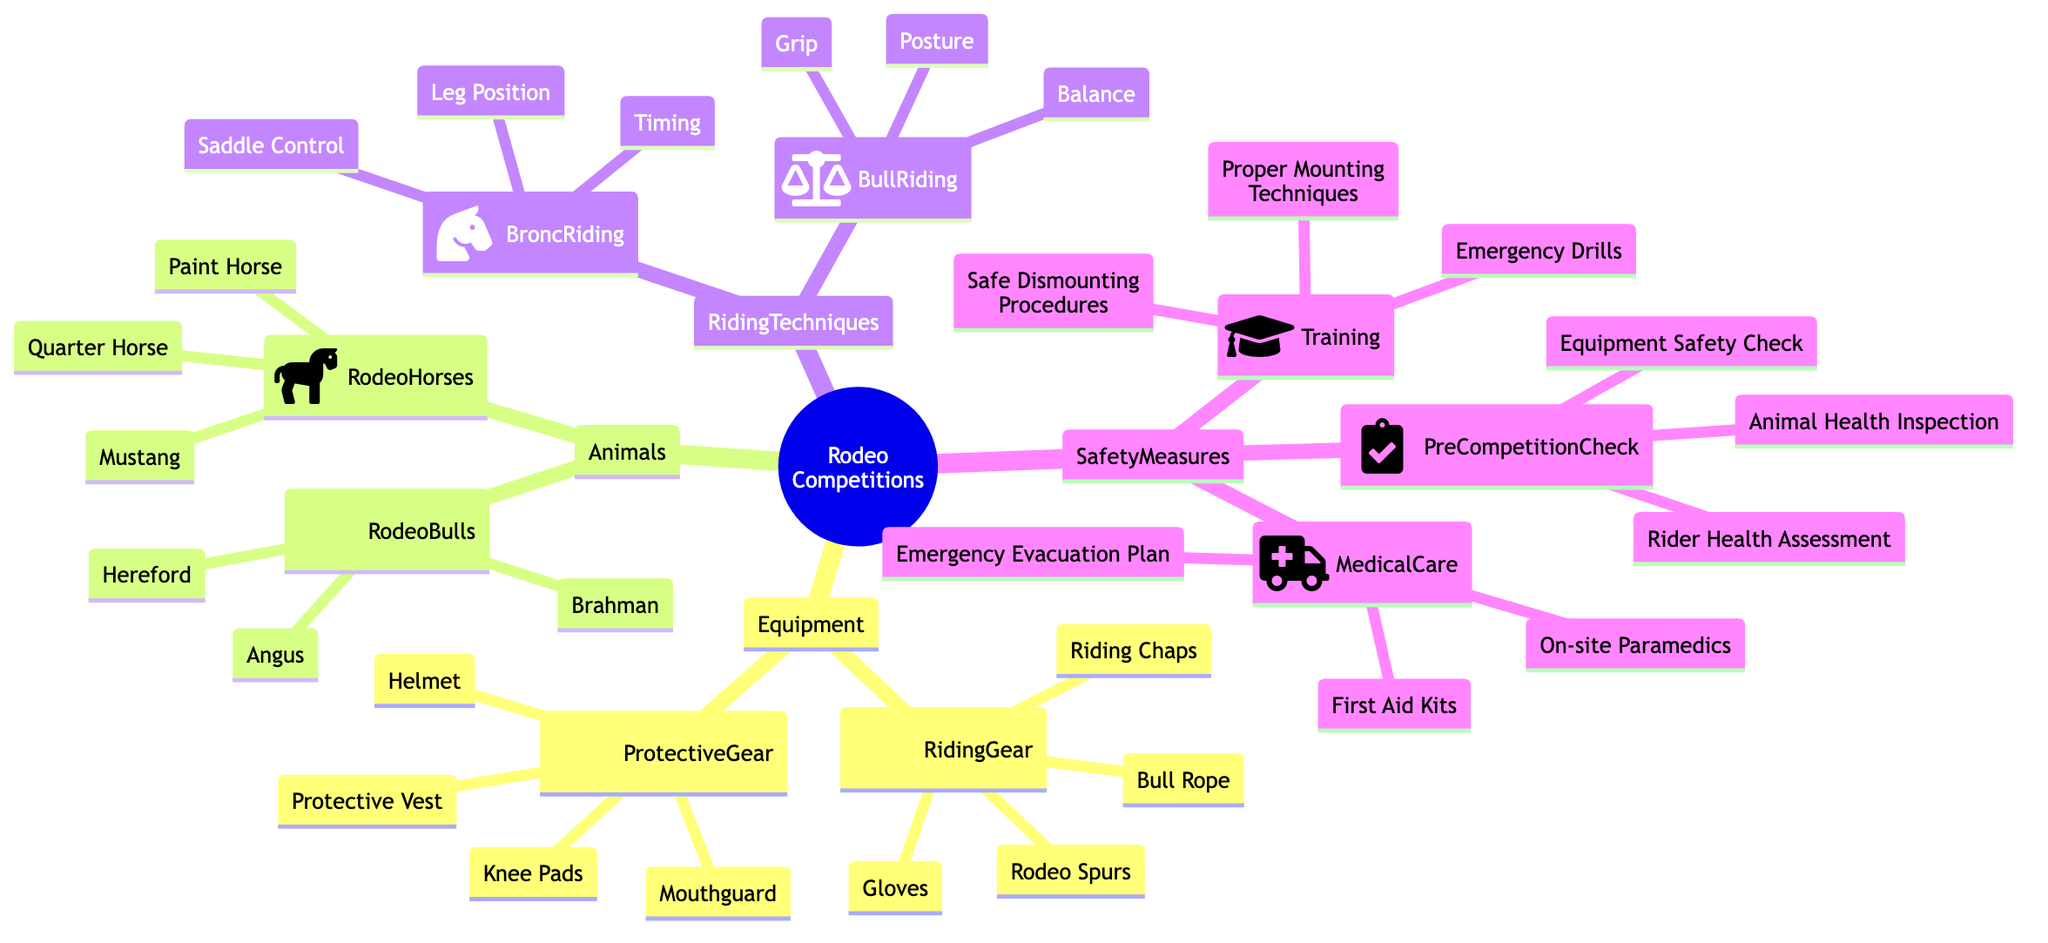What's included in the Riding Gear? The Riding Gear section lists four items: Rodeo Spurs, Riding Chaps, Bull Rope, and Gloves. These items are specifically categorized under the Equipment for Rodeo Competitions.
Answer: Rodeo Spurs, Riding Chaps, Bull Rope, Gloves How many types of Rodeo Bulls are listed? Under the Animals section, the Rodeo Bulls category contains three types: Brahman, Hereford, and Angus. Therefore, the count of Rodeo Bulls is three.
Answer: 3 What is one type of Protective Gear? The Protective Gear section mentions several items. One specific example from the listed items is the Helmet, which is commonly used for safety in rodeo competitions.
Answer: Helmet Which Riding Technique includes Leg Position? The Riding Techniques are divided into Bull Riding and Bronc Riding. Leg Position is specifically mentioned under the Bronc Riding category. Hence, the answer is Bronc Riding.
Answer: Bronc Riding What are the components of Medical Care safety measures? The Medical Care section has three components: On-site Paramedics, First Aid Kits, and Emergency Evacuation Plan. These items are crucial for ensuring medical assistance during competitions.
Answer: On-site Paramedics, First Aid Kits, Emergency Evacuation Plan How many items are listed under Pre-Competition Check? The Pre-Competition Check includes three distinct items: Animal Health Inspection, Equipment Safety Check, and Rider Health Assessment, making the total count three.
Answer: 3 Which category includes Emergency Drills? Emergency Drills are part of the Training category under Safety Measures. They are crucial for ensuring readiness for emergencies during rodeo events.
Answer: Training What distinguishes Bull Riding from Bronc Riding in riding techniques? Bull Riding focuses on Posture, Grip, and Balance, while Bronc Riding emphasizes Saddle Control, Leg Position, and Timing. Thus, the distinction lies in the specific techniques applied to each type of riding.
Answer: Bull Riding, Bronc Riding What type of horse is listed as a Rodeo Horse? The Rodeo Horses category includes various types, with one specific example being the Quarter Horse, which is traditionally used in rodeo events.
Answer: Quarter Horse 